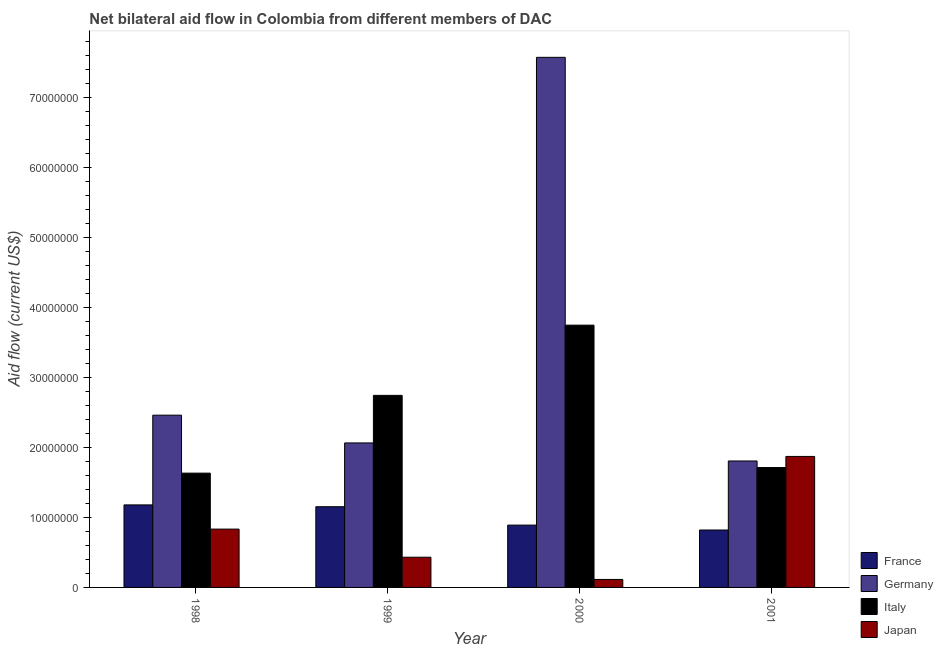How many different coloured bars are there?
Make the answer very short. 4. What is the amount of aid given by germany in 1999?
Make the answer very short. 2.07e+07. Across all years, what is the maximum amount of aid given by japan?
Your response must be concise. 1.87e+07. Across all years, what is the minimum amount of aid given by japan?
Provide a short and direct response. 1.14e+06. In which year was the amount of aid given by italy maximum?
Your answer should be very brief. 2000. What is the total amount of aid given by france in the graph?
Offer a very short reply. 4.05e+07. What is the difference between the amount of aid given by germany in 1998 and that in 2001?
Provide a succinct answer. 6.55e+06. What is the difference between the amount of aid given by japan in 2001 and the amount of aid given by france in 2000?
Give a very brief answer. 1.76e+07. What is the average amount of aid given by france per year?
Make the answer very short. 1.01e+07. In the year 1999, what is the difference between the amount of aid given by germany and amount of aid given by japan?
Offer a terse response. 0. In how many years, is the amount of aid given by france greater than 42000000 US$?
Your response must be concise. 0. What is the ratio of the amount of aid given by italy in 2000 to that in 2001?
Provide a short and direct response. 2.19. Is the difference between the amount of aid given by germany in 1999 and 2001 greater than the difference between the amount of aid given by japan in 1999 and 2001?
Make the answer very short. No. What is the difference between the highest and the second highest amount of aid given by italy?
Offer a terse response. 1.00e+07. What is the difference between the highest and the lowest amount of aid given by france?
Your answer should be compact. 3.59e+06. Is the sum of the amount of aid given by france in 2000 and 2001 greater than the maximum amount of aid given by japan across all years?
Your answer should be compact. Yes. Is it the case that in every year, the sum of the amount of aid given by germany and amount of aid given by italy is greater than the sum of amount of aid given by france and amount of aid given by japan?
Your answer should be very brief. No. What does the 3rd bar from the left in 1999 represents?
Your answer should be very brief. Italy. How many bars are there?
Your answer should be very brief. 16. What is the difference between two consecutive major ticks on the Y-axis?
Offer a terse response. 1.00e+07. Are the values on the major ticks of Y-axis written in scientific E-notation?
Give a very brief answer. No. Does the graph contain any zero values?
Make the answer very short. No. Does the graph contain grids?
Offer a terse response. No. Where does the legend appear in the graph?
Offer a terse response. Bottom right. How many legend labels are there?
Your answer should be compact. 4. How are the legend labels stacked?
Offer a terse response. Vertical. What is the title of the graph?
Make the answer very short. Net bilateral aid flow in Colombia from different members of DAC. Does "Social Awareness" appear as one of the legend labels in the graph?
Offer a very short reply. No. What is the label or title of the X-axis?
Offer a terse response. Year. What is the Aid flow (current US$) of France in 1998?
Provide a succinct answer. 1.18e+07. What is the Aid flow (current US$) of Germany in 1998?
Offer a very short reply. 2.46e+07. What is the Aid flow (current US$) of Italy in 1998?
Your answer should be compact. 1.63e+07. What is the Aid flow (current US$) in Japan in 1998?
Give a very brief answer. 8.34e+06. What is the Aid flow (current US$) of France in 1999?
Provide a short and direct response. 1.15e+07. What is the Aid flow (current US$) of Germany in 1999?
Give a very brief answer. 2.07e+07. What is the Aid flow (current US$) of Italy in 1999?
Provide a short and direct response. 2.75e+07. What is the Aid flow (current US$) in Japan in 1999?
Your answer should be very brief. 4.32e+06. What is the Aid flow (current US$) in France in 2000?
Offer a terse response. 8.91e+06. What is the Aid flow (current US$) of Germany in 2000?
Make the answer very short. 7.58e+07. What is the Aid flow (current US$) of Italy in 2000?
Provide a succinct answer. 3.75e+07. What is the Aid flow (current US$) of Japan in 2000?
Your response must be concise. 1.14e+06. What is the Aid flow (current US$) of France in 2001?
Provide a succinct answer. 8.21e+06. What is the Aid flow (current US$) of Germany in 2001?
Offer a very short reply. 1.81e+07. What is the Aid flow (current US$) of Italy in 2001?
Provide a succinct answer. 1.71e+07. What is the Aid flow (current US$) in Japan in 2001?
Provide a succinct answer. 1.87e+07. Across all years, what is the maximum Aid flow (current US$) in France?
Your answer should be compact. 1.18e+07. Across all years, what is the maximum Aid flow (current US$) in Germany?
Ensure brevity in your answer.  7.58e+07. Across all years, what is the maximum Aid flow (current US$) of Italy?
Your answer should be compact. 3.75e+07. Across all years, what is the maximum Aid flow (current US$) of Japan?
Your response must be concise. 1.87e+07. Across all years, what is the minimum Aid flow (current US$) in France?
Offer a terse response. 8.21e+06. Across all years, what is the minimum Aid flow (current US$) in Germany?
Offer a terse response. 1.81e+07. Across all years, what is the minimum Aid flow (current US$) in Italy?
Your answer should be very brief. 1.63e+07. Across all years, what is the minimum Aid flow (current US$) in Japan?
Provide a short and direct response. 1.14e+06. What is the total Aid flow (current US$) in France in the graph?
Your response must be concise. 4.05e+07. What is the total Aid flow (current US$) of Germany in the graph?
Your answer should be very brief. 1.39e+08. What is the total Aid flow (current US$) of Italy in the graph?
Give a very brief answer. 9.84e+07. What is the total Aid flow (current US$) in Japan in the graph?
Offer a very short reply. 3.25e+07. What is the difference between the Aid flow (current US$) in Germany in 1998 and that in 1999?
Your response must be concise. 3.97e+06. What is the difference between the Aid flow (current US$) of Italy in 1998 and that in 1999?
Offer a terse response. -1.11e+07. What is the difference between the Aid flow (current US$) in Japan in 1998 and that in 1999?
Give a very brief answer. 4.02e+06. What is the difference between the Aid flow (current US$) of France in 1998 and that in 2000?
Provide a short and direct response. 2.89e+06. What is the difference between the Aid flow (current US$) of Germany in 1998 and that in 2000?
Offer a very short reply. -5.12e+07. What is the difference between the Aid flow (current US$) in Italy in 1998 and that in 2000?
Your answer should be compact. -2.12e+07. What is the difference between the Aid flow (current US$) of Japan in 1998 and that in 2000?
Offer a very short reply. 7.20e+06. What is the difference between the Aid flow (current US$) in France in 1998 and that in 2001?
Keep it short and to the point. 3.59e+06. What is the difference between the Aid flow (current US$) of Germany in 1998 and that in 2001?
Your answer should be compact. 6.55e+06. What is the difference between the Aid flow (current US$) in Italy in 1998 and that in 2001?
Give a very brief answer. -8.00e+05. What is the difference between the Aid flow (current US$) of Japan in 1998 and that in 2001?
Provide a succinct answer. -1.04e+07. What is the difference between the Aid flow (current US$) in France in 1999 and that in 2000?
Ensure brevity in your answer.  2.63e+06. What is the difference between the Aid flow (current US$) in Germany in 1999 and that in 2000?
Offer a terse response. -5.51e+07. What is the difference between the Aid flow (current US$) in Italy in 1999 and that in 2000?
Offer a very short reply. -1.00e+07. What is the difference between the Aid flow (current US$) in Japan in 1999 and that in 2000?
Give a very brief answer. 3.18e+06. What is the difference between the Aid flow (current US$) in France in 1999 and that in 2001?
Offer a terse response. 3.33e+06. What is the difference between the Aid flow (current US$) of Germany in 1999 and that in 2001?
Keep it short and to the point. 2.58e+06. What is the difference between the Aid flow (current US$) of Italy in 1999 and that in 2001?
Give a very brief answer. 1.03e+07. What is the difference between the Aid flow (current US$) of Japan in 1999 and that in 2001?
Offer a very short reply. -1.44e+07. What is the difference between the Aid flow (current US$) of France in 2000 and that in 2001?
Keep it short and to the point. 7.00e+05. What is the difference between the Aid flow (current US$) of Germany in 2000 and that in 2001?
Offer a very short reply. 5.77e+07. What is the difference between the Aid flow (current US$) in Italy in 2000 and that in 2001?
Offer a terse response. 2.04e+07. What is the difference between the Aid flow (current US$) of Japan in 2000 and that in 2001?
Provide a succinct answer. -1.76e+07. What is the difference between the Aid flow (current US$) in France in 1998 and the Aid flow (current US$) in Germany in 1999?
Provide a short and direct response. -8.86e+06. What is the difference between the Aid flow (current US$) in France in 1998 and the Aid flow (current US$) in Italy in 1999?
Offer a very short reply. -1.57e+07. What is the difference between the Aid flow (current US$) of France in 1998 and the Aid flow (current US$) of Japan in 1999?
Your response must be concise. 7.48e+06. What is the difference between the Aid flow (current US$) in Germany in 1998 and the Aid flow (current US$) in Italy in 1999?
Offer a very short reply. -2.83e+06. What is the difference between the Aid flow (current US$) of Germany in 1998 and the Aid flow (current US$) of Japan in 1999?
Give a very brief answer. 2.03e+07. What is the difference between the Aid flow (current US$) in Italy in 1998 and the Aid flow (current US$) in Japan in 1999?
Offer a very short reply. 1.20e+07. What is the difference between the Aid flow (current US$) in France in 1998 and the Aid flow (current US$) in Germany in 2000?
Keep it short and to the point. -6.40e+07. What is the difference between the Aid flow (current US$) in France in 1998 and the Aid flow (current US$) in Italy in 2000?
Your answer should be very brief. -2.57e+07. What is the difference between the Aid flow (current US$) of France in 1998 and the Aid flow (current US$) of Japan in 2000?
Keep it short and to the point. 1.07e+07. What is the difference between the Aid flow (current US$) of Germany in 1998 and the Aid flow (current US$) of Italy in 2000?
Give a very brief answer. -1.29e+07. What is the difference between the Aid flow (current US$) of Germany in 1998 and the Aid flow (current US$) of Japan in 2000?
Ensure brevity in your answer.  2.35e+07. What is the difference between the Aid flow (current US$) in Italy in 1998 and the Aid flow (current US$) in Japan in 2000?
Give a very brief answer. 1.52e+07. What is the difference between the Aid flow (current US$) of France in 1998 and the Aid flow (current US$) of Germany in 2001?
Keep it short and to the point. -6.28e+06. What is the difference between the Aid flow (current US$) of France in 1998 and the Aid flow (current US$) of Italy in 2001?
Provide a short and direct response. -5.34e+06. What is the difference between the Aid flow (current US$) of France in 1998 and the Aid flow (current US$) of Japan in 2001?
Make the answer very short. -6.93e+06. What is the difference between the Aid flow (current US$) in Germany in 1998 and the Aid flow (current US$) in Italy in 2001?
Offer a terse response. 7.49e+06. What is the difference between the Aid flow (current US$) in Germany in 1998 and the Aid flow (current US$) in Japan in 2001?
Offer a very short reply. 5.90e+06. What is the difference between the Aid flow (current US$) in Italy in 1998 and the Aid flow (current US$) in Japan in 2001?
Your answer should be very brief. -2.39e+06. What is the difference between the Aid flow (current US$) in France in 1999 and the Aid flow (current US$) in Germany in 2000?
Offer a terse response. -6.42e+07. What is the difference between the Aid flow (current US$) in France in 1999 and the Aid flow (current US$) in Italy in 2000?
Your answer should be very brief. -2.60e+07. What is the difference between the Aid flow (current US$) in France in 1999 and the Aid flow (current US$) in Japan in 2000?
Offer a terse response. 1.04e+07. What is the difference between the Aid flow (current US$) in Germany in 1999 and the Aid flow (current US$) in Italy in 2000?
Ensure brevity in your answer.  -1.68e+07. What is the difference between the Aid flow (current US$) of Germany in 1999 and the Aid flow (current US$) of Japan in 2000?
Ensure brevity in your answer.  1.95e+07. What is the difference between the Aid flow (current US$) in Italy in 1999 and the Aid flow (current US$) in Japan in 2000?
Offer a very short reply. 2.63e+07. What is the difference between the Aid flow (current US$) of France in 1999 and the Aid flow (current US$) of Germany in 2001?
Provide a succinct answer. -6.54e+06. What is the difference between the Aid flow (current US$) of France in 1999 and the Aid flow (current US$) of Italy in 2001?
Provide a succinct answer. -5.60e+06. What is the difference between the Aid flow (current US$) in France in 1999 and the Aid flow (current US$) in Japan in 2001?
Keep it short and to the point. -7.19e+06. What is the difference between the Aid flow (current US$) of Germany in 1999 and the Aid flow (current US$) of Italy in 2001?
Your response must be concise. 3.52e+06. What is the difference between the Aid flow (current US$) in Germany in 1999 and the Aid flow (current US$) in Japan in 2001?
Provide a succinct answer. 1.93e+06. What is the difference between the Aid flow (current US$) in Italy in 1999 and the Aid flow (current US$) in Japan in 2001?
Make the answer very short. 8.73e+06. What is the difference between the Aid flow (current US$) in France in 2000 and the Aid flow (current US$) in Germany in 2001?
Give a very brief answer. -9.17e+06. What is the difference between the Aid flow (current US$) of France in 2000 and the Aid flow (current US$) of Italy in 2001?
Make the answer very short. -8.23e+06. What is the difference between the Aid flow (current US$) of France in 2000 and the Aid flow (current US$) of Japan in 2001?
Ensure brevity in your answer.  -9.82e+06. What is the difference between the Aid flow (current US$) of Germany in 2000 and the Aid flow (current US$) of Italy in 2001?
Your answer should be very brief. 5.86e+07. What is the difference between the Aid flow (current US$) of Germany in 2000 and the Aid flow (current US$) of Japan in 2001?
Provide a succinct answer. 5.71e+07. What is the difference between the Aid flow (current US$) in Italy in 2000 and the Aid flow (current US$) in Japan in 2001?
Ensure brevity in your answer.  1.88e+07. What is the average Aid flow (current US$) of France per year?
Give a very brief answer. 1.01e+07. What is the average Aid flow (current US$) in Germany per year?
Provide a succinct answer. 3.48e+07. What is the average Aid flow (current US$) in Italy per year?
Provide a succinct answer. 2.46e+07. What is the average Aid flow (current US$) of Japan per year?
Make the answer very short. 8.13e+06. In the year 1998, what is the difference between the Aid flow (current US$) in France and Aid flow (current US$) in Germany?
Give a very brief answer. -1.28e+07. In the year 1998, what is the difference between the Aid flow (current US$) in France and Aid flow (current US$) in Italy?
Your response must be concise. -4.54e+06. In the year 1998, what is the difference between the Aid flow (current US$) of France and Aid flow (current US$) of Japan?
Provide a short and direct response. 3.46e+06. In the year 1998, what is the difference between the Aid flow (current US$) in Germany and Aid flow (current US$) in Italy?
Offer a terse response. 8.29e+06. In the year 1998, what is the difference between the Aid flow (current US$) of Germany and Aid flow (current US$) of Japan?
Offer a very short reply. 1.63e+07. In the year 1998, what is the difference between the Aid flow (current US$) in Italy and Aid flow (current US$) in Japan?
Offer a terse response. 8.00e+06. In the year 1999, what is the difference between the Aid flow (current US$) in France and Aid flow (current US$) in Germany?
Give a very brief answer. -9.12e+06. In the year 1999, what is the difference between the Aid flow (current US$) of France and Aid flow (current US$) of Italy?
Your response must be concise. -1.59e+07. In the year 1999, what is the difference between the Aid flow (current US$) of France and Aid flow (current US$) of Japan?
Offer a terse response. 7.22e+06. In the year 1999, what is the difference between the Aid flow (current US$) in Germany and Aid flow (current US$) in Italy?
Provide a succinct answer. -6.80e+06. In the year 1999, what is the difference between the Aid flow (current US$) of Germany and Aid flow (current US$) of Japan?
Ensure brevity in your answer.  1.63e+07. In the year 1999, what is the difference between the Aid flow (current US$) in Italy and Aid flow (current US$) in Japan?
Make the answer very short. 2.31e+07. In the year 2000, what is the difference between the Aid flow (current US$) in France and Aid flow (current US$) in Germany?
Make the answer very short. -6.69e+07. In the year 2000, what is the difference between the Aid flow (current US$) in France and Aid flow (current US$) in Italy?
Keep it short and to the point. -2.86e+07. In the year 2000, what is the difference between the Aid flow (current US$) in France and Aid flow (current US$) in Japan?
Provide a succinct answer. 7.77e+06. In the year 2000, what is the difference between the Aid flow (current US$) of Germany and Aid flow (current US$) of Italy?
Offer a terse response. 3.83e+07. In the year 2000, what is the difference between the Aid flow (current US$) of Germany and Aid flow (current US$) of Japan?
Give a very brief answer. 7.46e+07. In the year 2000, what is the difference between the Aid flow (current US$) of Italy and Aid flow (current US$) of Japan?
Give a very brief answer. 3.64e+07. In the year 2001, what is the difference between the Aid flow (current US$) in France and Aid flow (current US$) in Germany?
Your answer should be compact. -9.87e+06. In the year 2001, what is the difference between the Aid flow (current US$) in France and Aid flow (current US$) in Italy?
Your answer should be compact. -8.93e+06. In the year 2001, what is the difference between the Aid flow (current US$) in France and Aid flow (current US$) in Japan?
Offer a terse response. -1.05e+07. In the year 2001, what is the difference between the Aid flow (current US$) in Germany and Aid flow (current US$) in Italy?
Keep it short and to the point. 9.40e+05. In the year 2001, what is the difference between the Aid flow (current US$) of Germany and Aid flow (current US$) of Japan?
Your response must be concise. -6.50e+05. In the year 2001, what is the difference between the Aid flow (current US$) of Italy and Aid flow (current US$) of Japan?
Ensure brevity in your answer.  -1.59e+06. What is the ratio of the Aid flow (current US$) of France in 1998 to that in 1999?
Your response must be concise. 1.02. What is the ratio of the Aid flow (current US$) of Germany in 1998 to that in 1999?
Provide a short and direct response. 1.19. What is the ratio of the Aid flow (current US$) of Italy in 1998 to that in 1999?
Offer a terse response. 0.59. What is the ratio of the Aid flow (current US$) of Japan in 1998 to that in 1999?
Provide a succinct answer. 1.93. What is the ratio of the Aid flow (current US$) in France in 1998 to that in 2000?
Keep it short and to the point. 1.32. What is the ratio of the Aid flow (current US$) of Germany in 1998 to that in 2000?
Ensure brevity in your answer.  0.33. What is the ratio of the Aid flow (current US$) in Italy in 1998 to that in 2000?
Your response must be concise. 0.44. What is the ratio of the Aid flow (current US$) in Japan in 1998 to that in 2000?
Provide a short and direct response. 7.32. What is the ratio of the Aid flow (current US$) in France in 1998 to that in 2001?
Your answer should be compact. 1.44. What is the ratio of the Aid flow (current US$) of Germany in 1998 to that in 2001?
Give a very brief answer. 1.36. What is the ratio of the Aid flow (current US$) in Italy in 1998 to that in 2001?
Provide a short and direct response. 0.95. What is the ratio of the Aid flow (current US$) of Japan in 1998 to that in 2001?
Your response must be concise. 0.45. What is the ratio of the Aid flow (current US$) in France in 1999 to that in 2000?
Ensure brevity in your answer.  1.3. What is the ratio of the Aid flow (current US$) in Germany in 1999 to that in 2000?
Ensure brevity in your answer.  0.27. What is the ratio of the Aid flow (current US$) in Italy in 1999 to that in 2000?
Offer a terse response. 0.73. What is the ratio of the Aid flow (current US$) in Japan in 1999 to that in 2000?
Offer a very short reply. 3.79. What is the ratio of the Aid flow (current US$) of France in 1999 to that in 2001?
Provide a succinct answer. 1.41. What is the ratio of the Aid flow (current US$) in Germany in 1999 to that in 2001?
Your response must be concise. 1.14. What is the ratio of the Aid flow (current US$) of Italy in 1999 to that in 2001?
Give a very brief answer. 1.6. What is the ratio of the Aid flow (current US$) in Japan in 1999 to that in 2001?
Offer a terse response. 0.23. What is the ratio of the Aid flow (current US$) of France in 2000 to that in 2001?
Offer a very short reply. 1.09. What is the ratio of the Aid flow (current US$) in Germany in 2000 to that in 2001?
Offer a terse response. 4.19. What is the ratio of the Aid flow (current US$) of Italy in 2000 to that in 2001?
Your answer should be compact. 2.19. What is the ratio of the Aid flow (current US$) of Japan in 2000 to that in 2001?
Offer a terse response. 0.06. What is the difference between the highest and the second highest Aid flow (current US$) of France?
Offer a terse response. 2.60e+05. What is the difference between the highest and the second highest Aid flow (current US$) in Germany?
Offer a terse response. 5.12e+07. What is the difference between the highest and the second highest Aid flow (current US$) of Italy?
Provide a succinct answer. 1.00e+07. What is the difference between the highest and the second highest Aid flow (current US$) of Japan?
Keep it short and to the point. 1.04e+07. What is the difference between the highest and the lowest Aid flow (current US$) of France?
Your answer should be very brief. 3.59e+06. What is the difference between the highest and the lowest Aid flow (current US$) in Germany?
Provide a succinct answer. 5.77e+07. What is the difference between the highest and the lowest Aid flow (current US$) in Italy?
Offer a very short reply. 2.12e+07. What is the difference between the highest and the lowest Aid flow (current US$) of Japan?
Provide a short and direct response. 1.76e+07. 